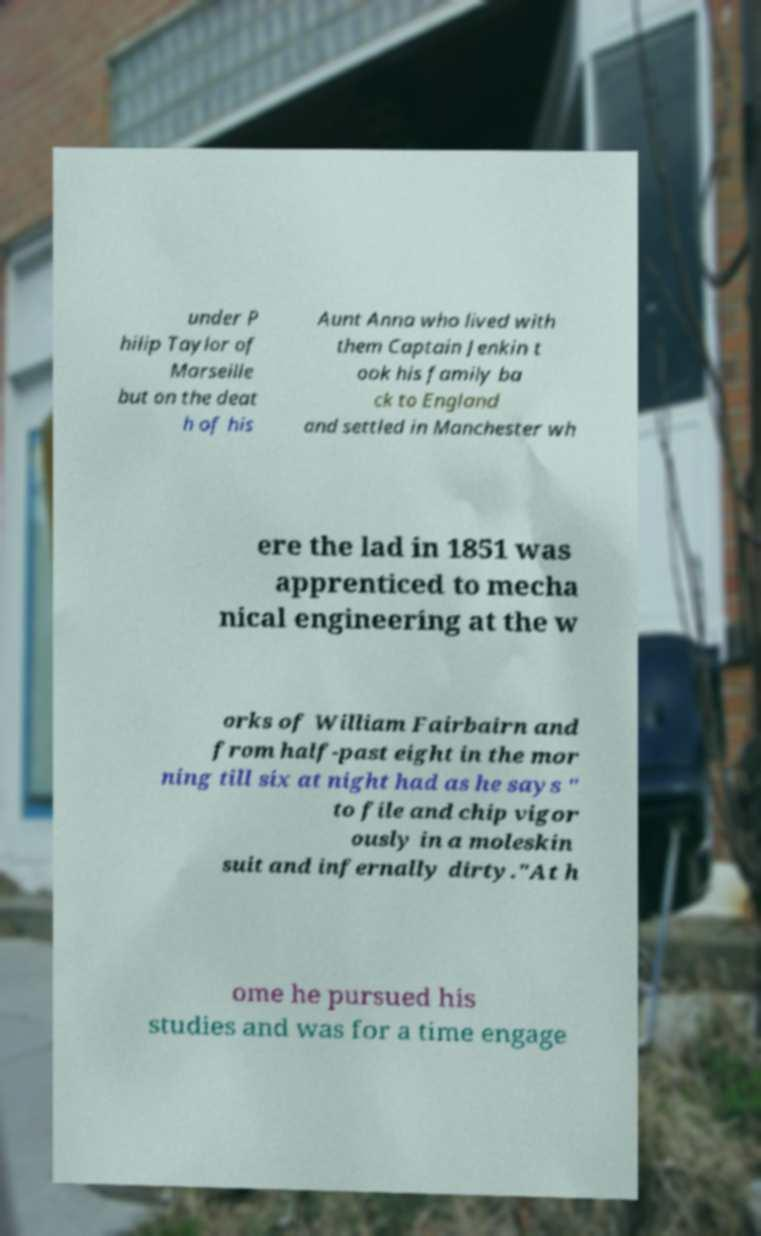For documentation purposes, I need the text within this image transcribed. Could you provide that? under P hilip Taylor of Marseille but on the deat h of his Aunt Anna who lived with them Captain Jenkin t ook his family ba ck to England and settled in Manchester wh ere the lad in 1851 was apprenticed to mecha nical engineering at the w orks of William Fairbairn and from half-past eight in the mor ning till six at night had as he says " to file and chip vigor ously in a moleskin suit and infernally dirty."At h ome he pursued his studies and was for a time engage 